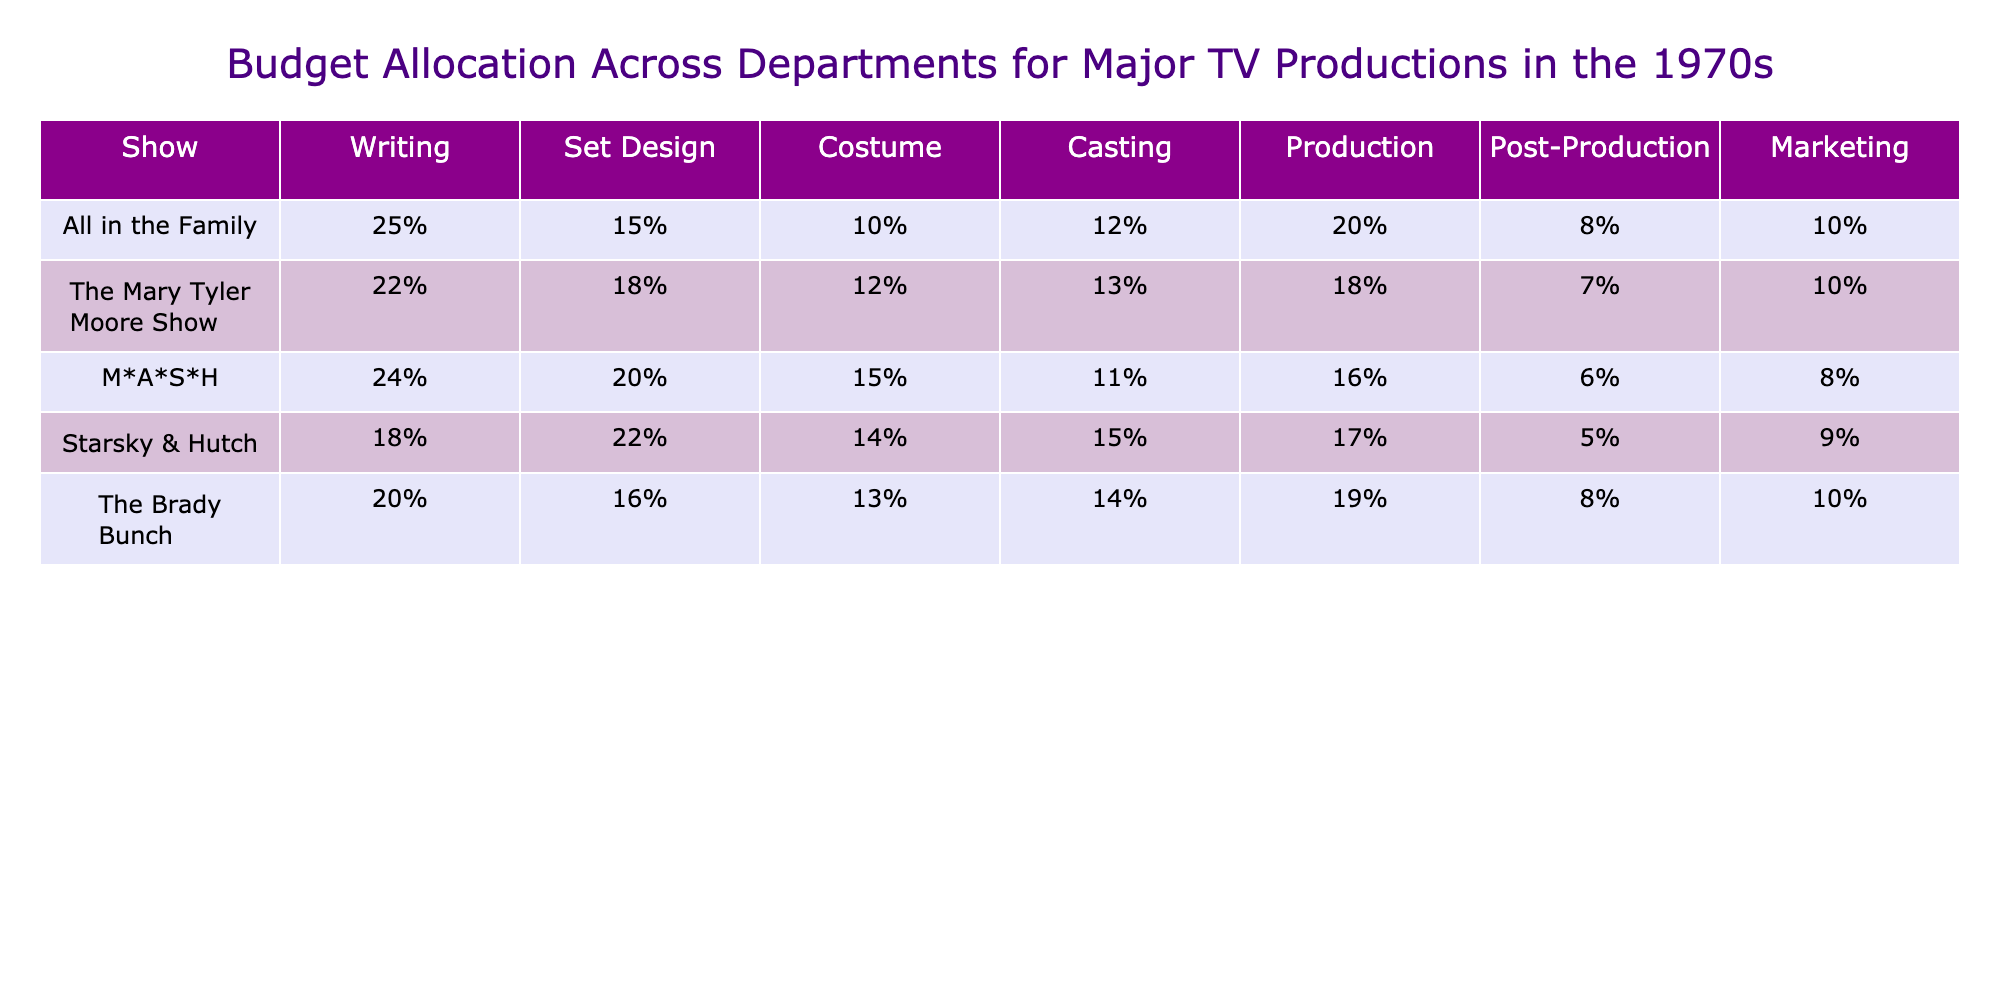What is the budget percentage for casting in "M*A*S*H"? In the table, the row for casting shows that "M*A*S*H" has a budget allocation of 11%.
Answer: 11% Which show allocated the highest percentage for set design? By comparing the set design percentages for all shows, "Starsky & Hutch" has the highest allocation at 22%.
Answer: Starsky & Hutch What is the average budget allocation for writing across all shows? The writing percentages are 25%, 22%, 24%, 18%, and 20%. Adding these up gives 25 + 22 + 24 + 18 + 20 = 109. Dividing 109 by 5 (the number of shows) gives an average of 21.8%.
Answer: 21.8% Which show has the lowest percentage allocated to post-production? Looking at the post-production row, "Starsky & Hutch" has the lowest allocation at 5%.
Answer: Starsky & Hutch Does "The Brady Bunch" have a higher percentage for marketing than "The Mary Tyler Moore Show"? For marketing, "The Brady Bunch" has 10% while "The Mary Tyler Moore Show" also has 10%. Since both show the same allocation, the answer is no.
Answer: No What is the difference in budget allocation for production between "All in the Family" and "M*A*S*H"? "All in the Family" has a production allocation of 20% and "M*A*S*H" has 16%. The difference is calculated as 20% - 16% = 4%.
Answer: 4% Which departments had a higher allocation in "The Mary Tyler Moore Show" compared to "The Brady Bunch"? For this comparison, let's look at all departments. In "The Mary Tyler Moore Show," set design (18% vs 16%), costume (12% vs 13%), and casting (13% vs 14%) are pertinent. Set design and production are higher in "The Mary Tyler Moore Show" while the others are lower.
Answer: Set design and production If we sum the budget percentages of all departments for "All in the Family", what is the total? The percentages for "All in the Family" are: writing (25%), set design (15%), costume (10%), casting (12%), production (20%), post-production (8%), and marketing (10%). Adding these gives 25 + 15 + 10 + 12 + 20 + 8 + 10 = 100%.
Answer: 100% Which show has the highest budget allocation for production and what is the percentage? Observing the production row, "The Brady Bunch" has the highest allocation at 19%.
Answer: The Brady Bunch, 19% What percentage of the budget is allocated to writing across all shows, and how does it compare to the average of all departments for "Starsky & Hutch"? Writing's overall budget allocation is 109% summed up. For "Starsky & Hutch," each department averages total (including writing) which leads us to check its allocation. The average across all departments for "Starsky & Hutch" is 17%. Writing is higher than that average.
Answer: Writing is higher 